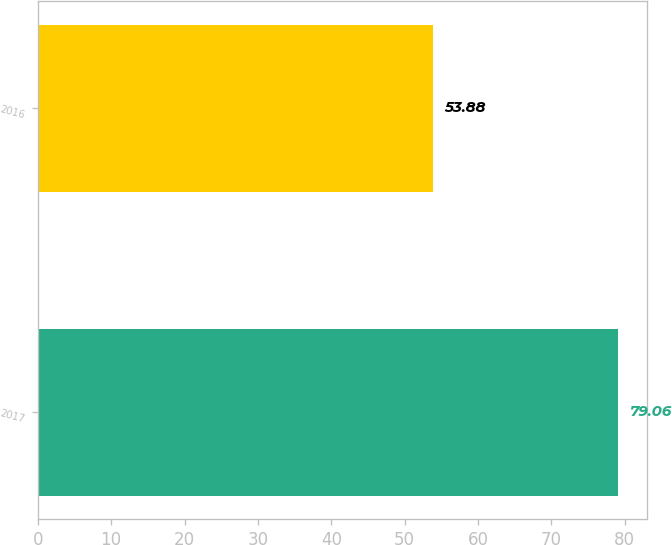<chart> <loc_0><loc_0><loc_500><loc_500><bar_chart><fcel>2017<fcel>2016<nl><fcel>79.06<fcel>53.88<nl></chart> 